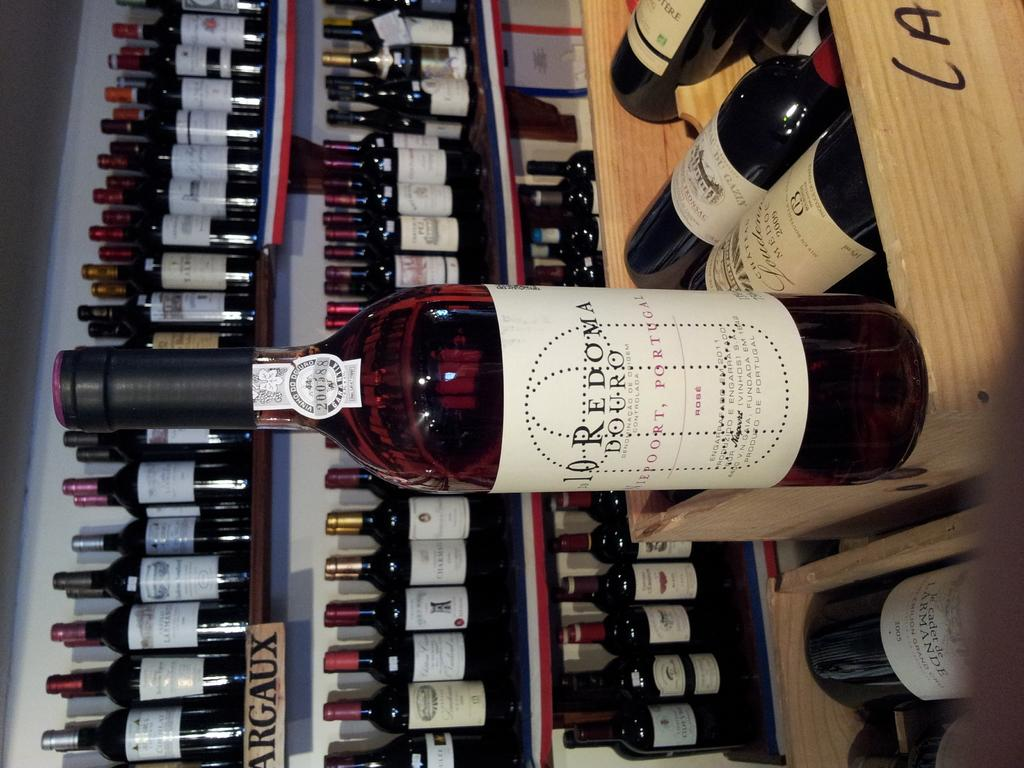What is the main object in the image? There is a bottle with a sticker in the image. Can you describe the background of the image? In the background of the image, there are many bottles placed in a rack. What type of creature is interacting with the bottle in the image? There is no creature present in the image; it only features a bottle with a sticker and a background with many bottles in a rack. 